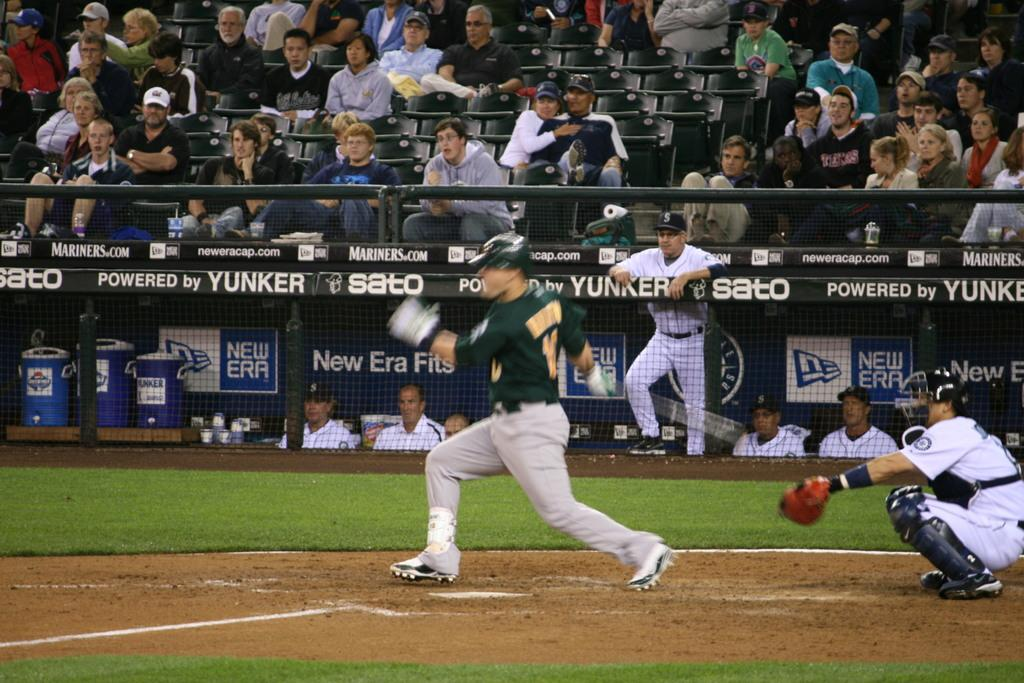<image>
Give a short and clear explanation of the subsequent image. A baseball player takes a swing with New Era ads in the background 